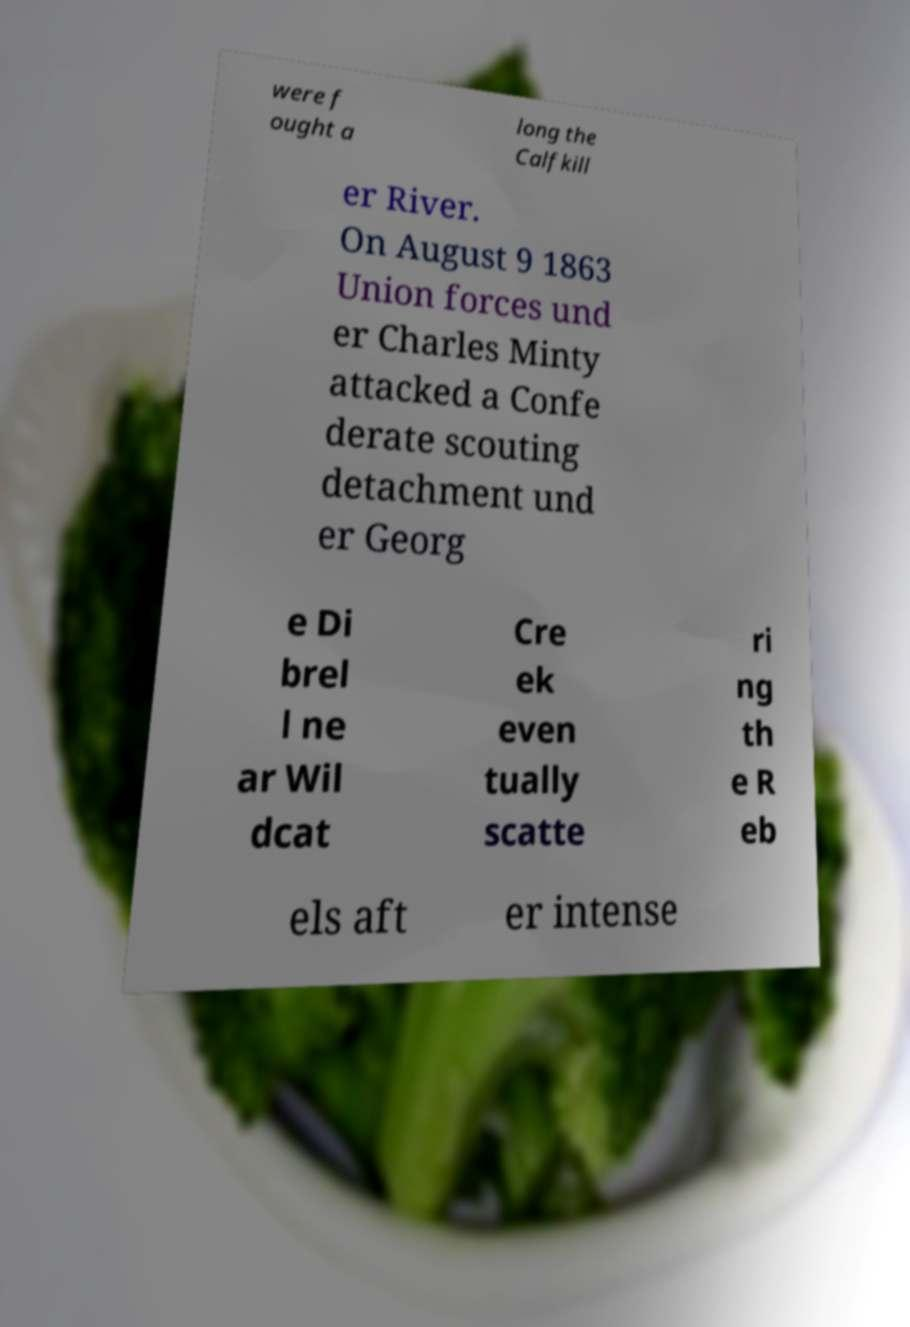I need the written content from this picture converted into text. Can you do that? were f ought a long the Calfkill er River. On August 9 1863 Union forces und er Charles Minty attacked a Confe derate scouting detachment und er Georg e Di brel l ne ar Wil dcat Cre ek even tually scatte ri ng th e R eb els aft er intense 